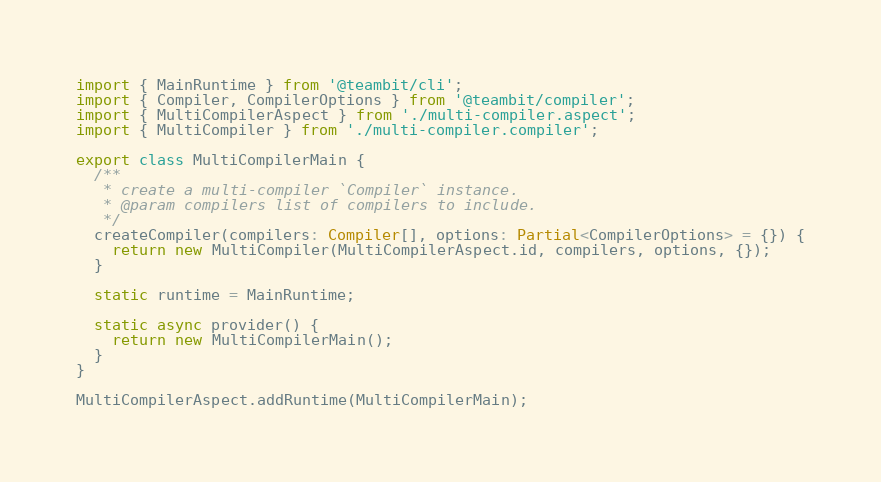Convert code to text. <code><loc_0><loc_0><loc_500><loc_500><_TypeScript_>import { MainRuntime } from '@teambit/cli';
import { Compiler, CompilerOptions } from '@teambit/compiler';
import { MultiCompilerAspect } from './multi-compiler.aspect';
import { MultiCompiler } from './multi-compiler.compiler';

export class MultiCompilerMain {
  /**
   * create a multi-compiler `Compiler` instance.
   * @param compilers list of compilers to include.
   */
  createCompiler(compilers: Compiler[], options: Partial<CompilerOptions> = {}) {
    return new MultiCompiler(MultiCompilerAspect.id, compilers, options, {});
  }

  static runtime = MainRuntime;

  static async provider() {
    return new MultiCompilerMain();
  }
}

MultiCompilerAspect.addRuntime(MultiCompilerMain);
</code> 